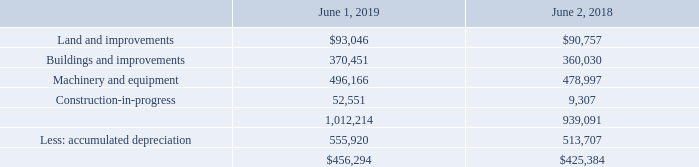6. Property, Plant and Equipment
Property, plant and equipment consisted of the following (in thousands):
Depreciation expense was $51.7 million, $51.1 million and $48.8 million in fiscal years 2019, 2018 and 2017, respectively.
The Company maintains insurance for both property damage and business interruption relating to catastrophic events, such as fires. Insurance recoveries received for property damage and business interruption in excess of the net book value of damaged assets, clean-up and demolition costs, and post-event costs are recognized as income in the period received or committed when all contingencies associated with the recoveries are resolved. Gains on insurance recoveries related to business interruption are recorded within “Cost of sales” and any gains or losses related to property damage are recorded within “Other income (expense).” Insurance recoveries related to business interruption are classified as operating cash flows and recoveries related to property damage are classified as investing cash flows in the statement of cash flows. Insurance claims incurred or finalized during the fiscal years ended 2019, 2018, and 2017 did not have a material affect on the Company's consolidated financial statements.
What was the depreciation expense in 2019? $51.7 million. What is the average building and improvements?
Answer scale should be: thousand. (370,451 + 360,030) / 2
Answer: 365240.5. What is the percentage increase in accumulated depreciation from 2018 to 2019?
Answer scale should be: percent. 555,920 / 513,707 - 1
Answer: 8.22. What is the average land and improvements?
Answer scale should be: thousand. (93,046 + 90,757) / 2
Answer: 91901.5. What are insurance recoveries related to business interruption classified as? Operating cash flows. What are recoveries related to property damage are classified as? Investing cash flows. 